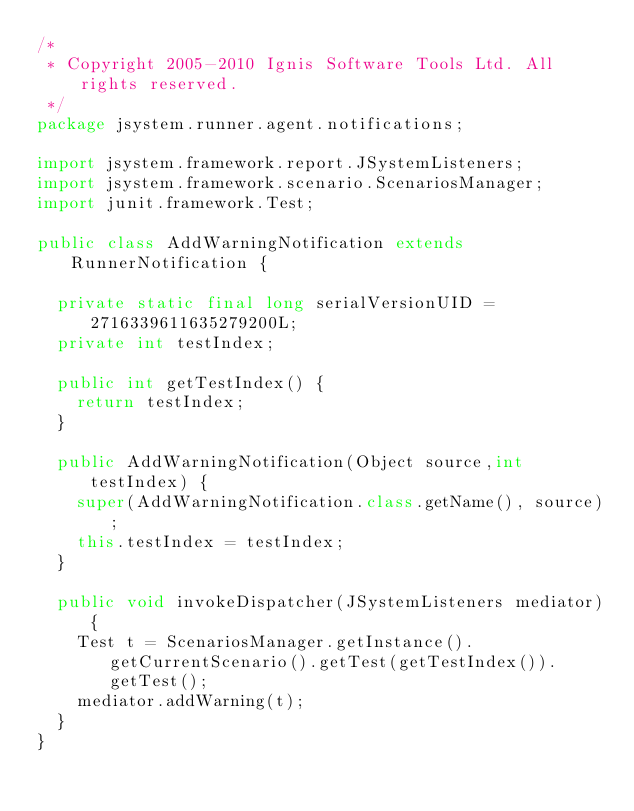<code> <loc_0><loc_0><loc_500><loc_500><_Java_>/*
 * Copyright 2005-2010 Ignis Software Tools Ltd. All rights reserved.
 */
package jsystem.runner.agent.notifications;

import jsystem.framework.report.JSystemListeners;
import jsystem.framework.scenario.ScenariosManager;
import junit.framework.Test;

public class AddWarningNotification extends RunnerNotification {
	
	private static final long serialVersionUID = 2716339611635279200L;
	private int testIndex;

	public int getTestIndex() {
		return testIndex;
	}

	public AddWarningNotification(Object source,int testIndex) {
		super(AddWarningNotification.class.getName(), source);
		this.testIndex = testIndex;
	}

	public void invokeDispatcher(JSystemListeners mediator){
		Test t = ScenariosManager.getInstance().getCurrentScenario().getTest(getTestIndex()).getTest();
		mediator.addWarning(t);
	}
}
</code> 